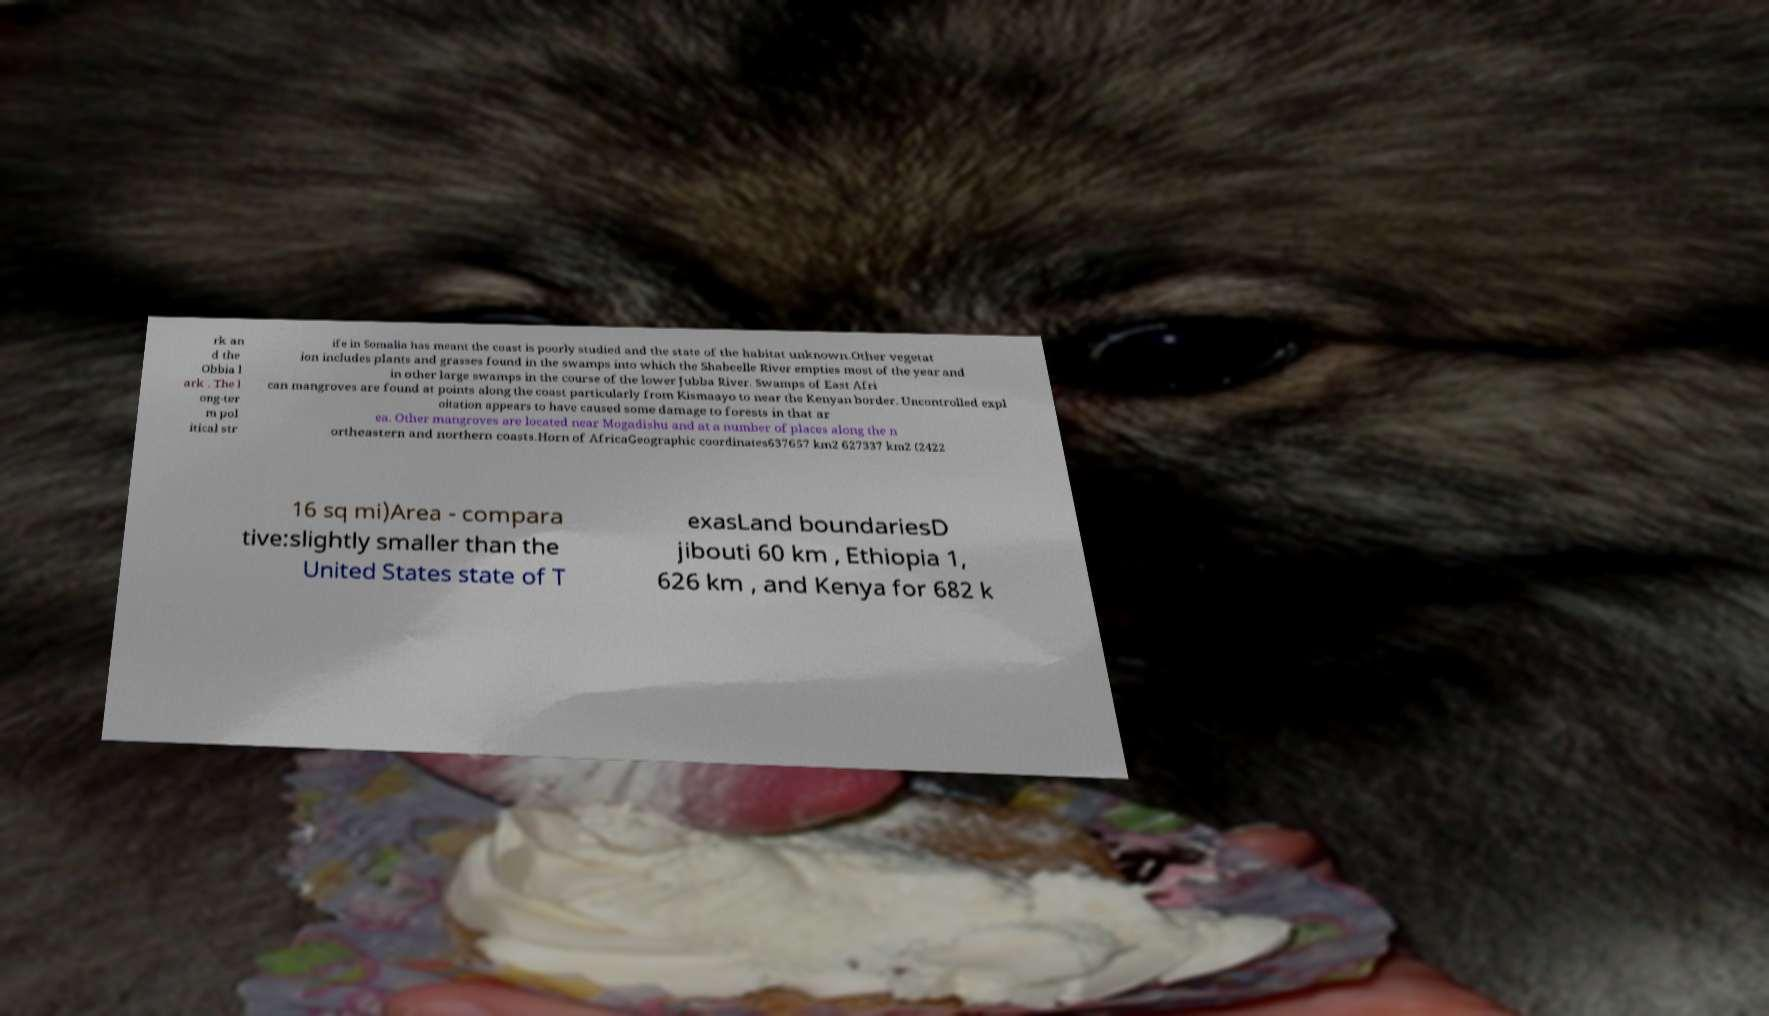Could you assist in decoding the text presented in this image and type it out clearly? rk an d the Obbia l ark . The l ong-ter m pol itical str ife in Somalia has meant the coast is poorly studied and the state of the habitat unknown.Other vegetat ion includes plants and grasses found in the swamps into which the Shabeelle River empties most of the year and in other large swamps in the course of the lower Jubba River. Swamps of East Afri can mangroves are found at points along the coast particularly from Kismaayo to near the Kenyan border. Uncontrolled expl oitation appears to have caused some damage to forests in that ar ea. Other mangroves are located near Mogadishu and at a number of places along the n ortheastern and northern coasts.Horn of AfricaGeographic coordinates637657 km2 627337 km2 (2422 16 sq mi)Area - compara tive:slightly smaller than the United States state of T exasLand boundariesD jibouti 60 km , Ethiopia 1, 626 km , and Kenya for 682 k 